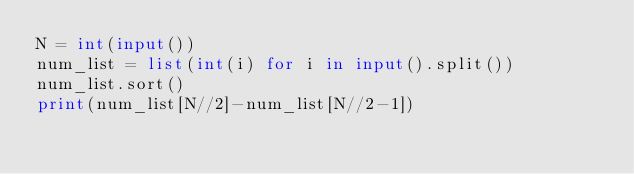Convert code to text. <code><loc_0><loc_0><loc_500><loc_500><_Python_>N = int(input())
num_list = list(int(i) for i in input().split())
num_list.sort()
print(num_list[N//2]-num_list[N//2-1])</code> 